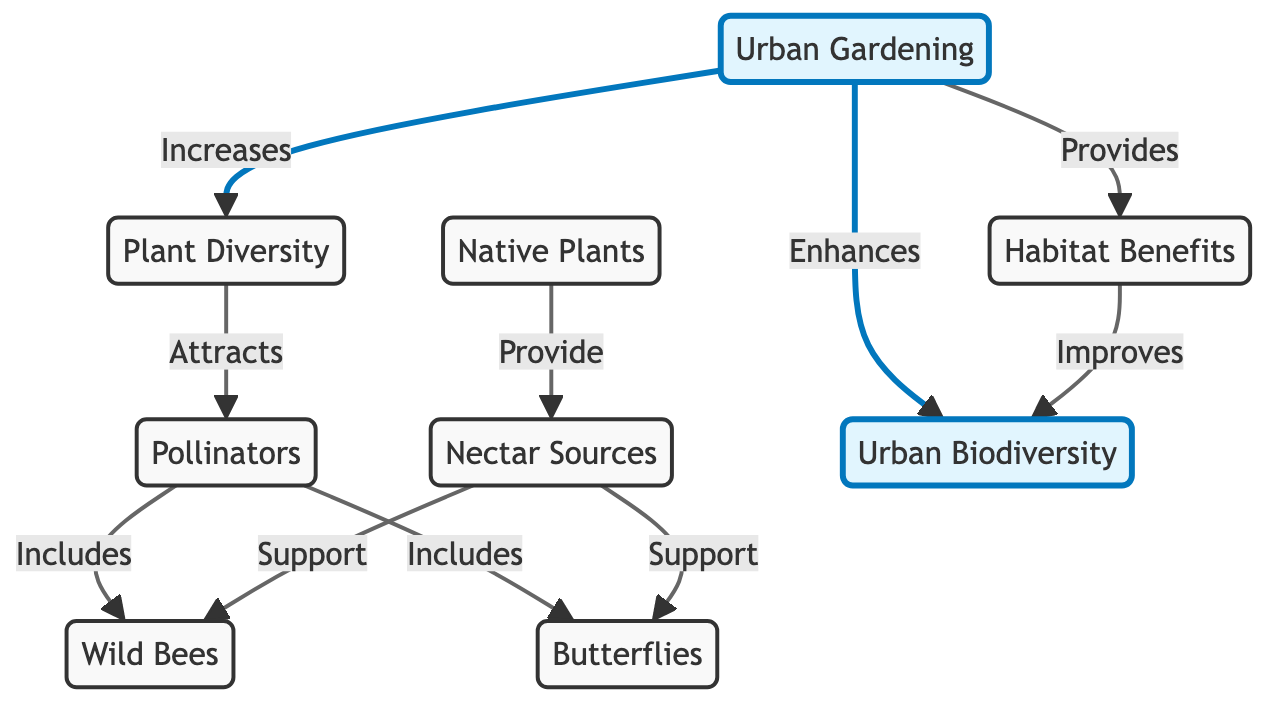What does urban gardening increase? The diagram indicates that urban gardening (UG) increases plant diversity (PD). This flows directly from the UG node to the PD node, showing a clear relationship.
Answer: Plant diversity How many types of pollinators are mentioned in the diagram? The diagram has two types of pollinators listed: wild bees (WB) and butterflies (B). By counting the nodes branching from the pollinator node (P), we identify these two distinct types.
Answer: Two What do native plants provide? The diagram indicates that native plants (NP) provide nectar sources (NS). This relationship is clearly depicted as an arrow leading from NP to NS.
Answer: Nectar sources How does urban gardening enhance urban biodiversity? Urban gardening (UG) enhances urban biodiversity (UB) indirectly by first increasing plant diversity (PD), which leads to attracting pollinators (P) and ultimately contributes to improved urban biodiversity. This flows sequentially from UG to PD, then to P, and finally to UB.
Answer: By increasing plant diversity What type of benefits does urban gardening provide? According to the diagram, urban gardening provides habitat benefits (HB), as indicated by the direct connection from the UG node to the HB node.
Answer: Habitat benefits How do nectar sources support wild bees? The diagram shows that nectar sources (NS) support wild bees (WB). This connection is directly illustrated by the arrow that leads from NS to WB. Thus, nectar sources contribute to the support of wild bees in the ecosystem.
Answer: They support wild bees Which element improves urban biodiversity? The diagram specifies two elements that improve urban biodiversity (UB): habitat benefits (HB) and urban gardening (UG). Both are linked to the UB node, indicating they contribute positively to urban biodiversity.
Answer: Habitat benefits and urban gardening What is the initial impact of urban gardening on the neighborhood ecosystem? The initial impact of urban gardening (UG) on the neighborhood ecosystem is an increase in plant diversity (PD), as represented by the direct connection from UG to PD. Thus, the first effect is an increase in the variety of plants.
Answer: An increase in plant diversity 